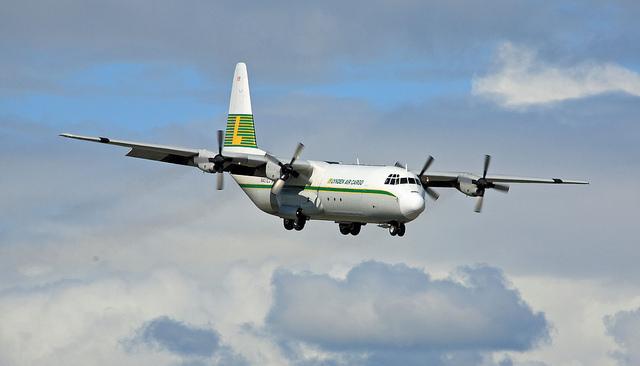How many propellers are there?
Quick response, please. 4. What is the letter on the plane?
Give a very brief answer. L. Is there any blue sky showing?
Short answer required. Yes. What is the weather like?
Be succinct. Cloudy. 